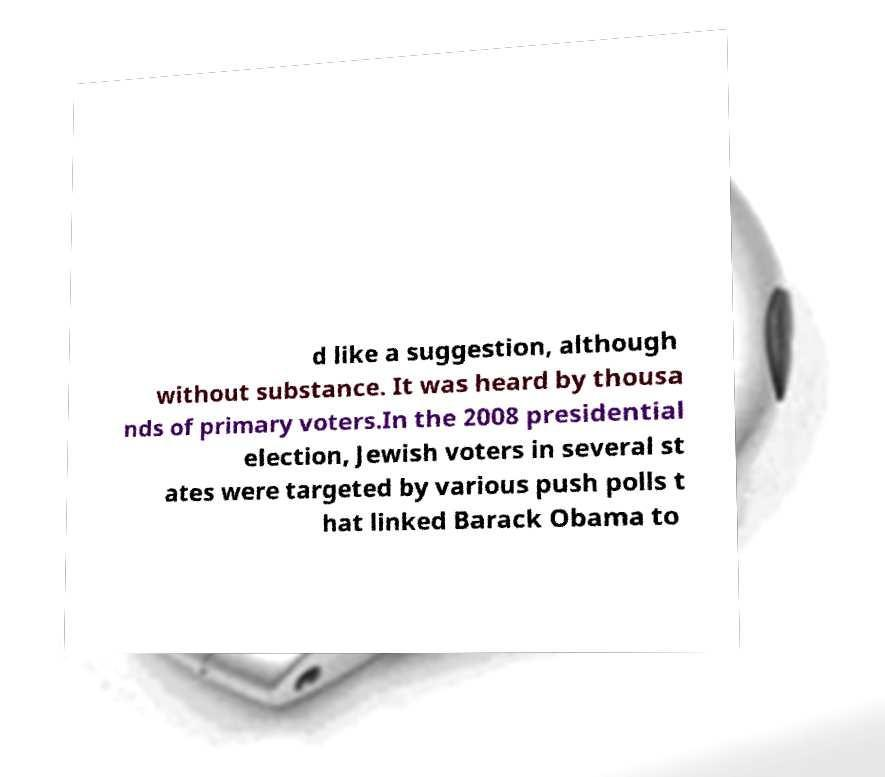Could you extract and type out the text from this image? d like a suggestion, although without substance. It was heard by thousa nds of primary voters.In the 2008 presidential election, Jewish voters in several st ates were targeted by various push polls t hat linked Barack Obama to 